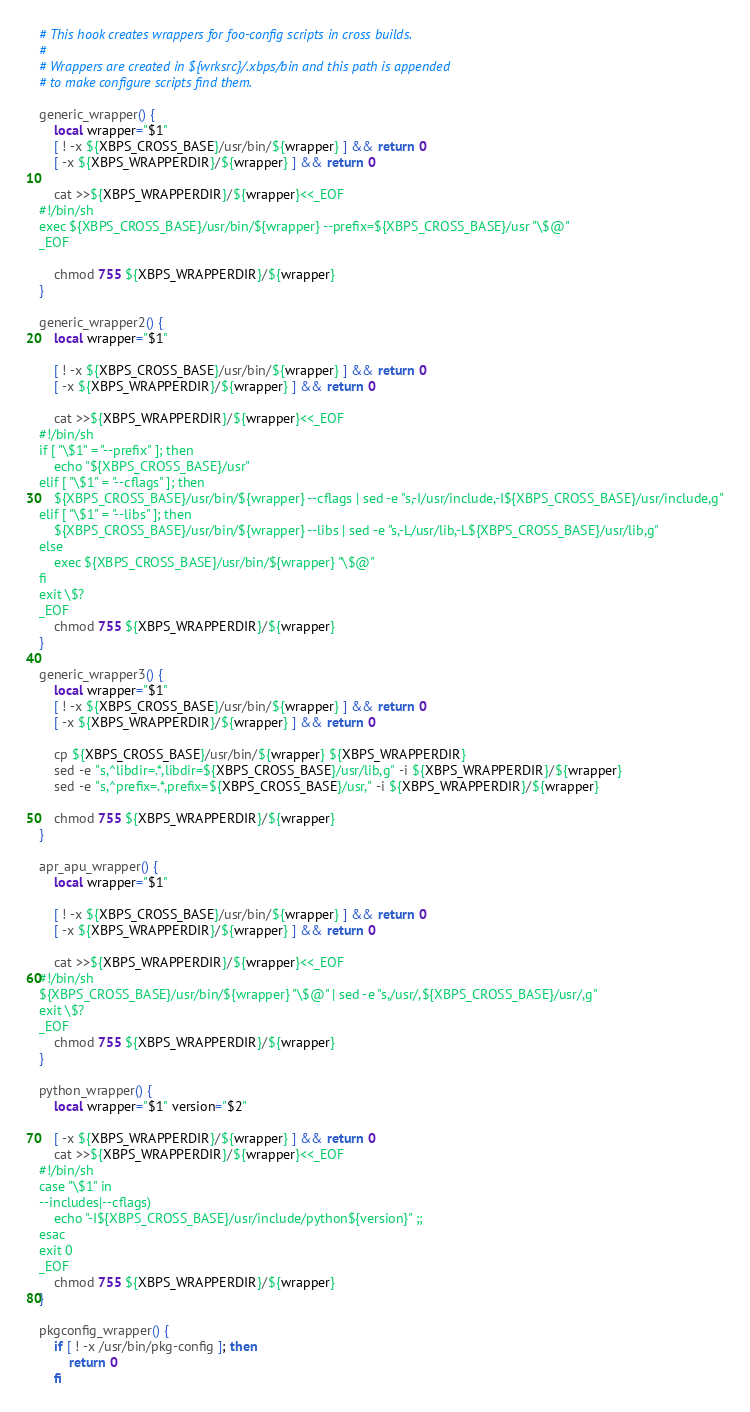<code> <loc_0><loc_0><loc_500><loc_500><_Bash_># This hook creates wrappers for foo-config scripts in cross builds.
#
# Wrappers are created in ${wrksrc}/.xbps/bin and this path is appended
# to make configure scripts find them.

generic_wrapper() {
	local wrapper="$1"
	[ ! -x ${XBPS_CROSS_BASE}/usr/bin/${wrapper} ] && return 0
	[ -x ${XBPS_WRAPPERDIR}/${wrapper} ] && return 0

	cat >>${XBPS_WRAPPERDIR}/${wrapper}<<_EOF
#!/bin/sh
exec ${XBPS_CROSS_BASE}/usr/bin/${wrapper} --prefix=${XBPS_CROSS_BASE}/usr "\$@"
_EOF

	chmod 755 ${XBPS_WRAPPERDIR}/${wrapper}
}

generic_wrapper2() {
	local wrapper="$1"

	[ ! -x ${XBPS_CROSS_BASE}/usr/bin/${wrapper} ] && return 0
	[ -x ${XBPS_WRAPPERDIR}/${wrapper} ] && return 0

	cat >>${XBPS_WRAPPERDIR}/${wrapper}<<_EOF
#!/bin/sh
if [ "\$1" = "--prefix" ]; then
	echo "${XBPS_CROSS_BASE}/usr"
elif [ "\$1" = "--cflags" ]; then
	${XBPS_CROSS_BASE}/usr/bin/${wrapper} --cflags | sed -e "s,-I/usr/include,-I${XBPS_CROSS_BASE}/usr/include,g"
elif [ "\$1" = "--libs" ]; then
	${XBPS_CROSS_BASE}/usr/bin/${wrapper} --libs | sed -e "s,-L/usr/lib,-L${XBPS_CROSS_BASE}/usr/lib,g"
else
	exec ${XBPS_CROSS_BASE}/usr/bin/${wrapper} "\$@"
fi
exit \$?
_EOF
	chmod 755 ${XBPS_WRAPPERDIR}/${wrapper}
}

generic_wrapper3() {
	local wrapper="$1"
	[ ! -x ${XBPS_CROSS_BASE}/usr/bin/${wrapper} ] && return 0
	[ -x ${XBPS_WRAPPERDIR}/${wrapper} ] && return 0

	cp ${XBPS_CROSS_BASE}/usr/bin/${wrapper} ${XBPS_WRAPPERDIR}
	sed -e "s,^libdir=.*,libdir=${XBPS_CROSS_BASE}/usr/lib,g" -i ${XBPS_WRAPPERDIR}/${wrapper}
	sed -e "s,^prefix=.*,prefix=${XBPS_CROSS_BASE}/usr," -i ${XBPS_WRAPPERDIR}/${wrapper}

	chmod 755 ${XBPS_WRAPPERDIR}/${wrapper}
}

apr_apu_wrapper() {
	local wrapper="$1"

	[ ! -x ${XBPS_CROSS_BASE}/usr/bin/${wrapper} ] && return 0
	[ -x ${XBPS_WRAPPERDIR}/${wrapper} ] && return 0

	cat >>${XBPS_WRAPPERDIR}/${wrapper}<<_EOF
#!/bin/sh
${XBPS_CROSS_BASE}/usr/bin/${wrapper} "\$@" | sed -e "s,/usr/,${XBPS_CROSS_BASE}/usr/,g"
exit \$?
_EOF
	chmod 755 ${XBPS_WRAPPERDIR}/${wrapper}
}

python_wrapper() {
	local wrapper="$1" version="$2"

	[ -x ${XBPS_WRAPPERDIR}/${wrapper} ] && return 0
	cat >>${XBPS_WRAPPERDIR}/${wrapper}<<_EOF
#!/bin/sh
case "\$1" in
--includes|--cflags)
	echo "-I${XBPS_CROSS_BASE}/usr/include/python${version}" ;;
esac
exit 0
_EOF
	chmod 755 ${XBPS_WRAPPERDIR}/${wrapper}
}

pkgconfig_wrapper() {
	if [ ! -x /usr/bin/pkg-config ]; then
		return 0
	fi</code> 